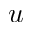Convert formula to latex. <formula><loc_0><loc_0><loc_500><loc_500>u</formula> 